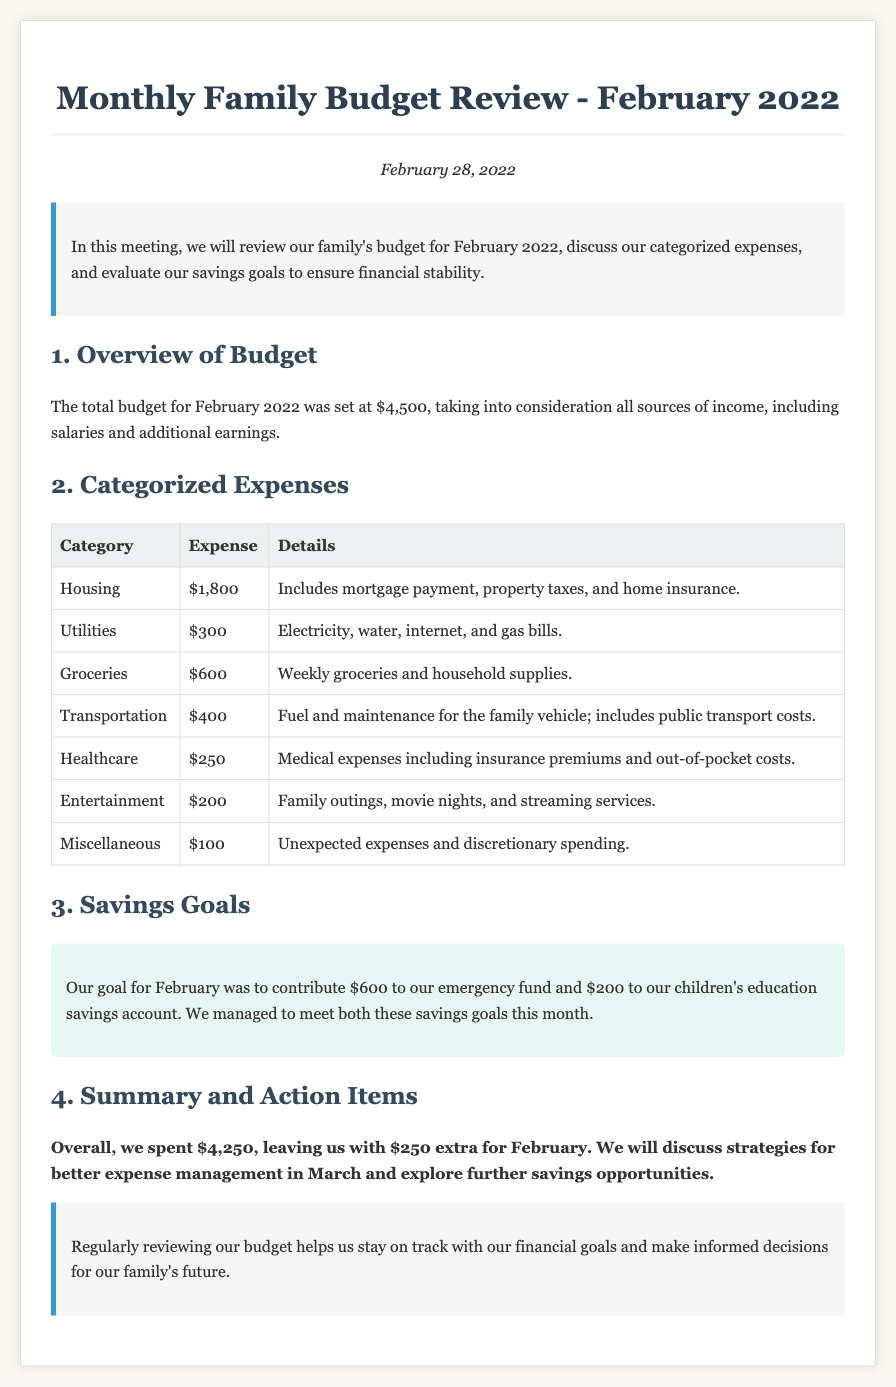what was the total budget for February 2022? The total budget is stated in the document as $4,500.
Answer: $4,500 how much was spent on Housing? The expense category for Housing indicates a total of $1,800.
Answer: $1,800 what are the two savings goals for February? The savings goals were to contribute to the emergency fund and children's education savings account, specified as $600 and $200 respectively.
Answer: $600 and $200 how much did the family spend on Healthcare? The document lists the expense for Healthcare as $250.
Answer: $250 what was the total amount spent in February? The total amount spent is calculated from the listed expenses and is stated as $4,250.
Answer: $4,250 how much extra money was left over after expenses? The document states that after all expenses, $250 remained.
Answer: $250 what was the total utility expense? The Utilities expense is indicated as $300 in the document.
Answer: $300 what is described in the introduction? The introduction outlines the purpose of reviewing the family’s budget, categorized expenses, and savings goals.
Answer: Review of budget, expenses, and savings goals how did the family perform against their savings goals? The document notes that the family managed to meet both savings goals for February.
Answer: Met both savings goals 